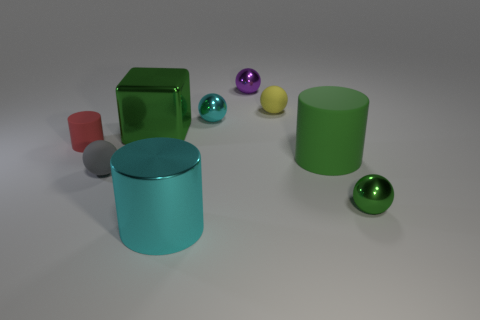Subtract all rubber balls. How many balls are left? 3 Subtract all green cylinders. How many cylinders are left? 2 Subtract 1 cubes. How many cubes are left? 0 Subtract all cylinders. How many objects are left? 6 Subtract all cyan balls. Subtract all purple cylinders. How many balls are left? 4 Subtract all cyan blocks. How many green cylinders are left? 1 Subtract all big green metallic cubes. Subtract all big cyan things. How many objects are left? 7 Add 3 tiny green metal balls. How many tiny green metal balls are left? 4 Add 1 tiny rubber cylinders. How many tiny rubber cylinders exist? 2 Subtract 1 green blocks. How many objects are left? 8 